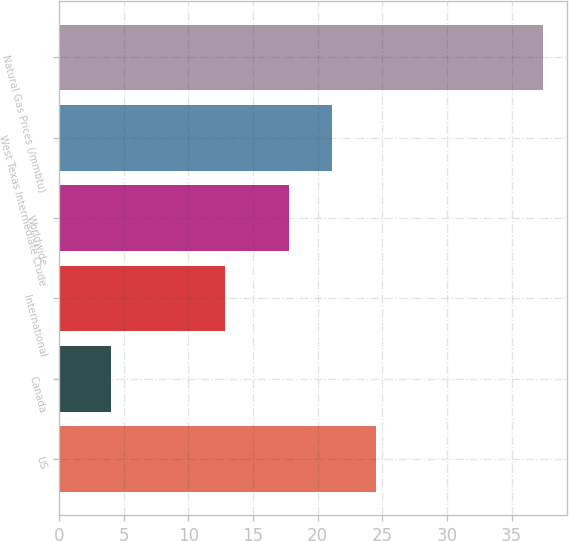<chart> <loc_0><loc_0><loc_500><loc_500><bar_chart><fcel>US<fcel>Canada<fcel>International<fcel>Worldwide<fcel>West Texas Intermediate Crude<fcel>Natural Gas Prices (/mmbtu)<nl><fcel>24.5<fcel>4<fcel>12.8<fcel>17.8<fcel>21.14<fcel>37.4<nl></chart> 